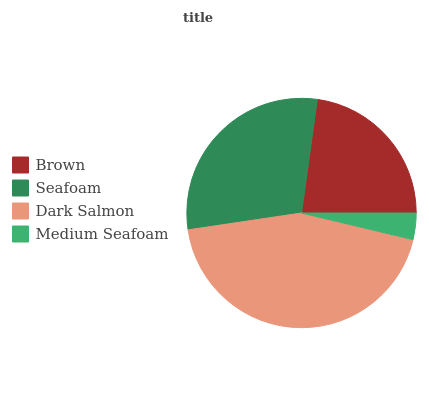Is Medium Seafoam the minimum?
Answer yes or no. Yes. Is Dark Salmon the maximum?
Answer yes or no. Yes. Is Seafoam the minimum?
Answer yes or no. No. Is Seafoam the maximum?
Answer yes or no. No. Is Seafoam greater than Brown?
Answer yes or no. Yes. Is Brown less than Seafoam?
Answer yes or no. Yes. Is Brown greater than Seafoam?
Answer yes or no. No. Is Seafoam less than Brown?
Answer yes or no. No. Is Seafoam the high median?
Answer yes or no. Yes. Is Brown the low median?
Answer yes or no. Yes. Is Medium Seafoam the high median?
Answer yes or no. No. Is Dark Salmon the low median?
Answer yes or no. No. 